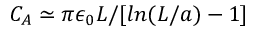Convert formula to latex. <formula><loc_0><loc_0><loc_500><loc_500>C _ { A } \simeq \pi \epsilon _ { 0 } L / [ \ln ( L / a ) - 1 ]</formula> 